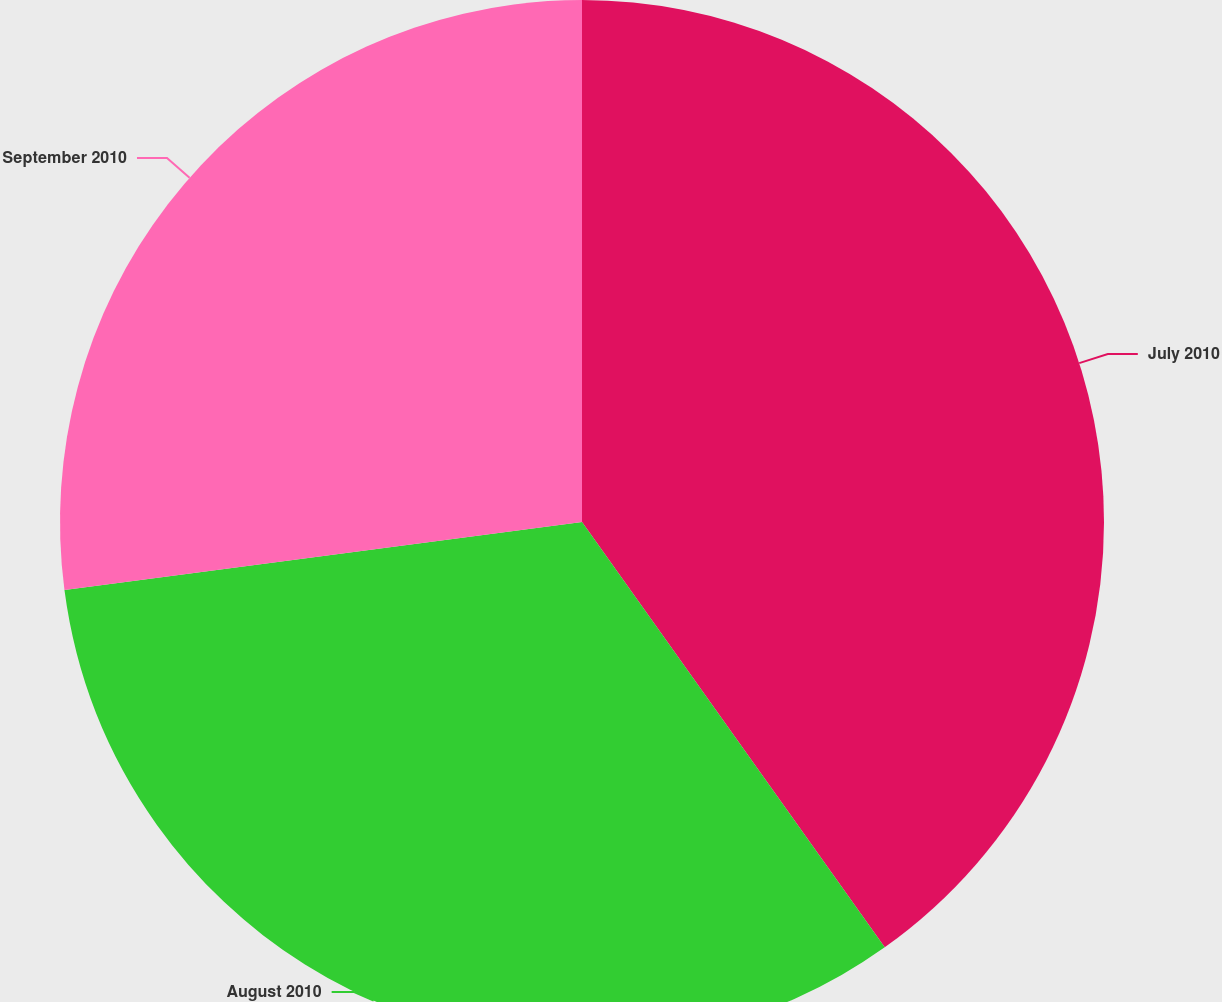Convert chart. <chart><loc_0><loc_0><loc_500><loc_500><pie_chart><fcel>July 2010<fcel>August 2010<fcel>September 2010<nl><fcel>40.15%<fcel>32.76%<fcel>27.08%<nl></chart> 